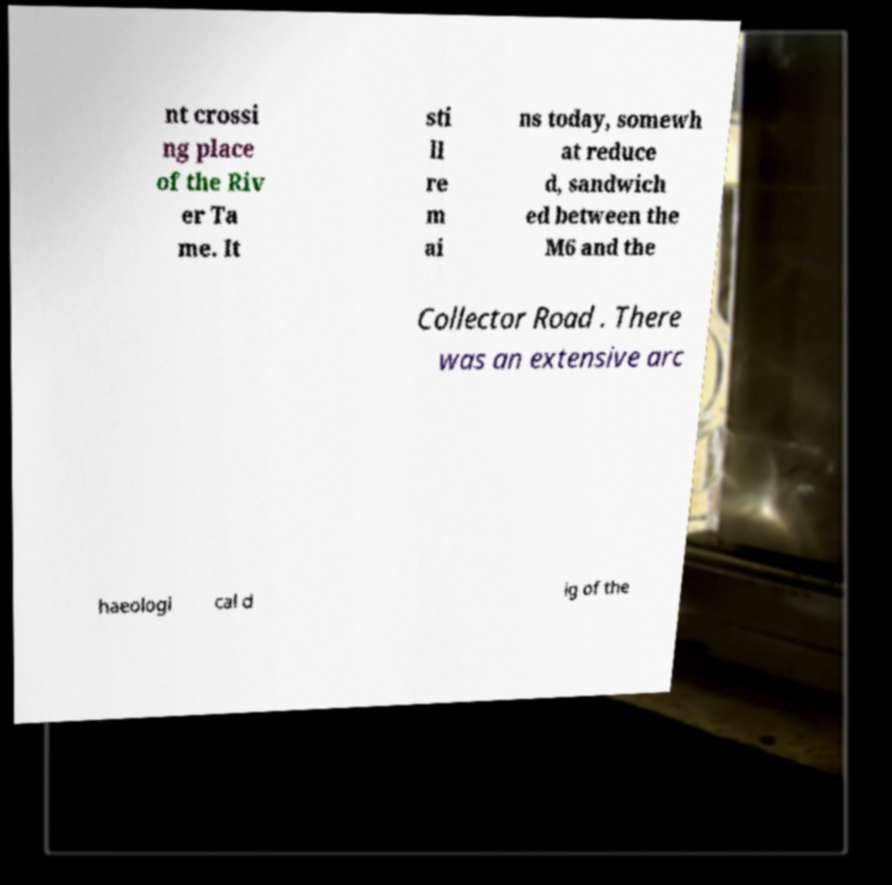For documentation purposes, I need the text within this image transcribed. Could you provide that? nt crossi ng place of the Riv er Ta me. It sti ll re m ai ns today, somewh at reduce d, sandwich ed between the M6 and the Collector Road . There was an extensive arc haeologi cal d ig of the 